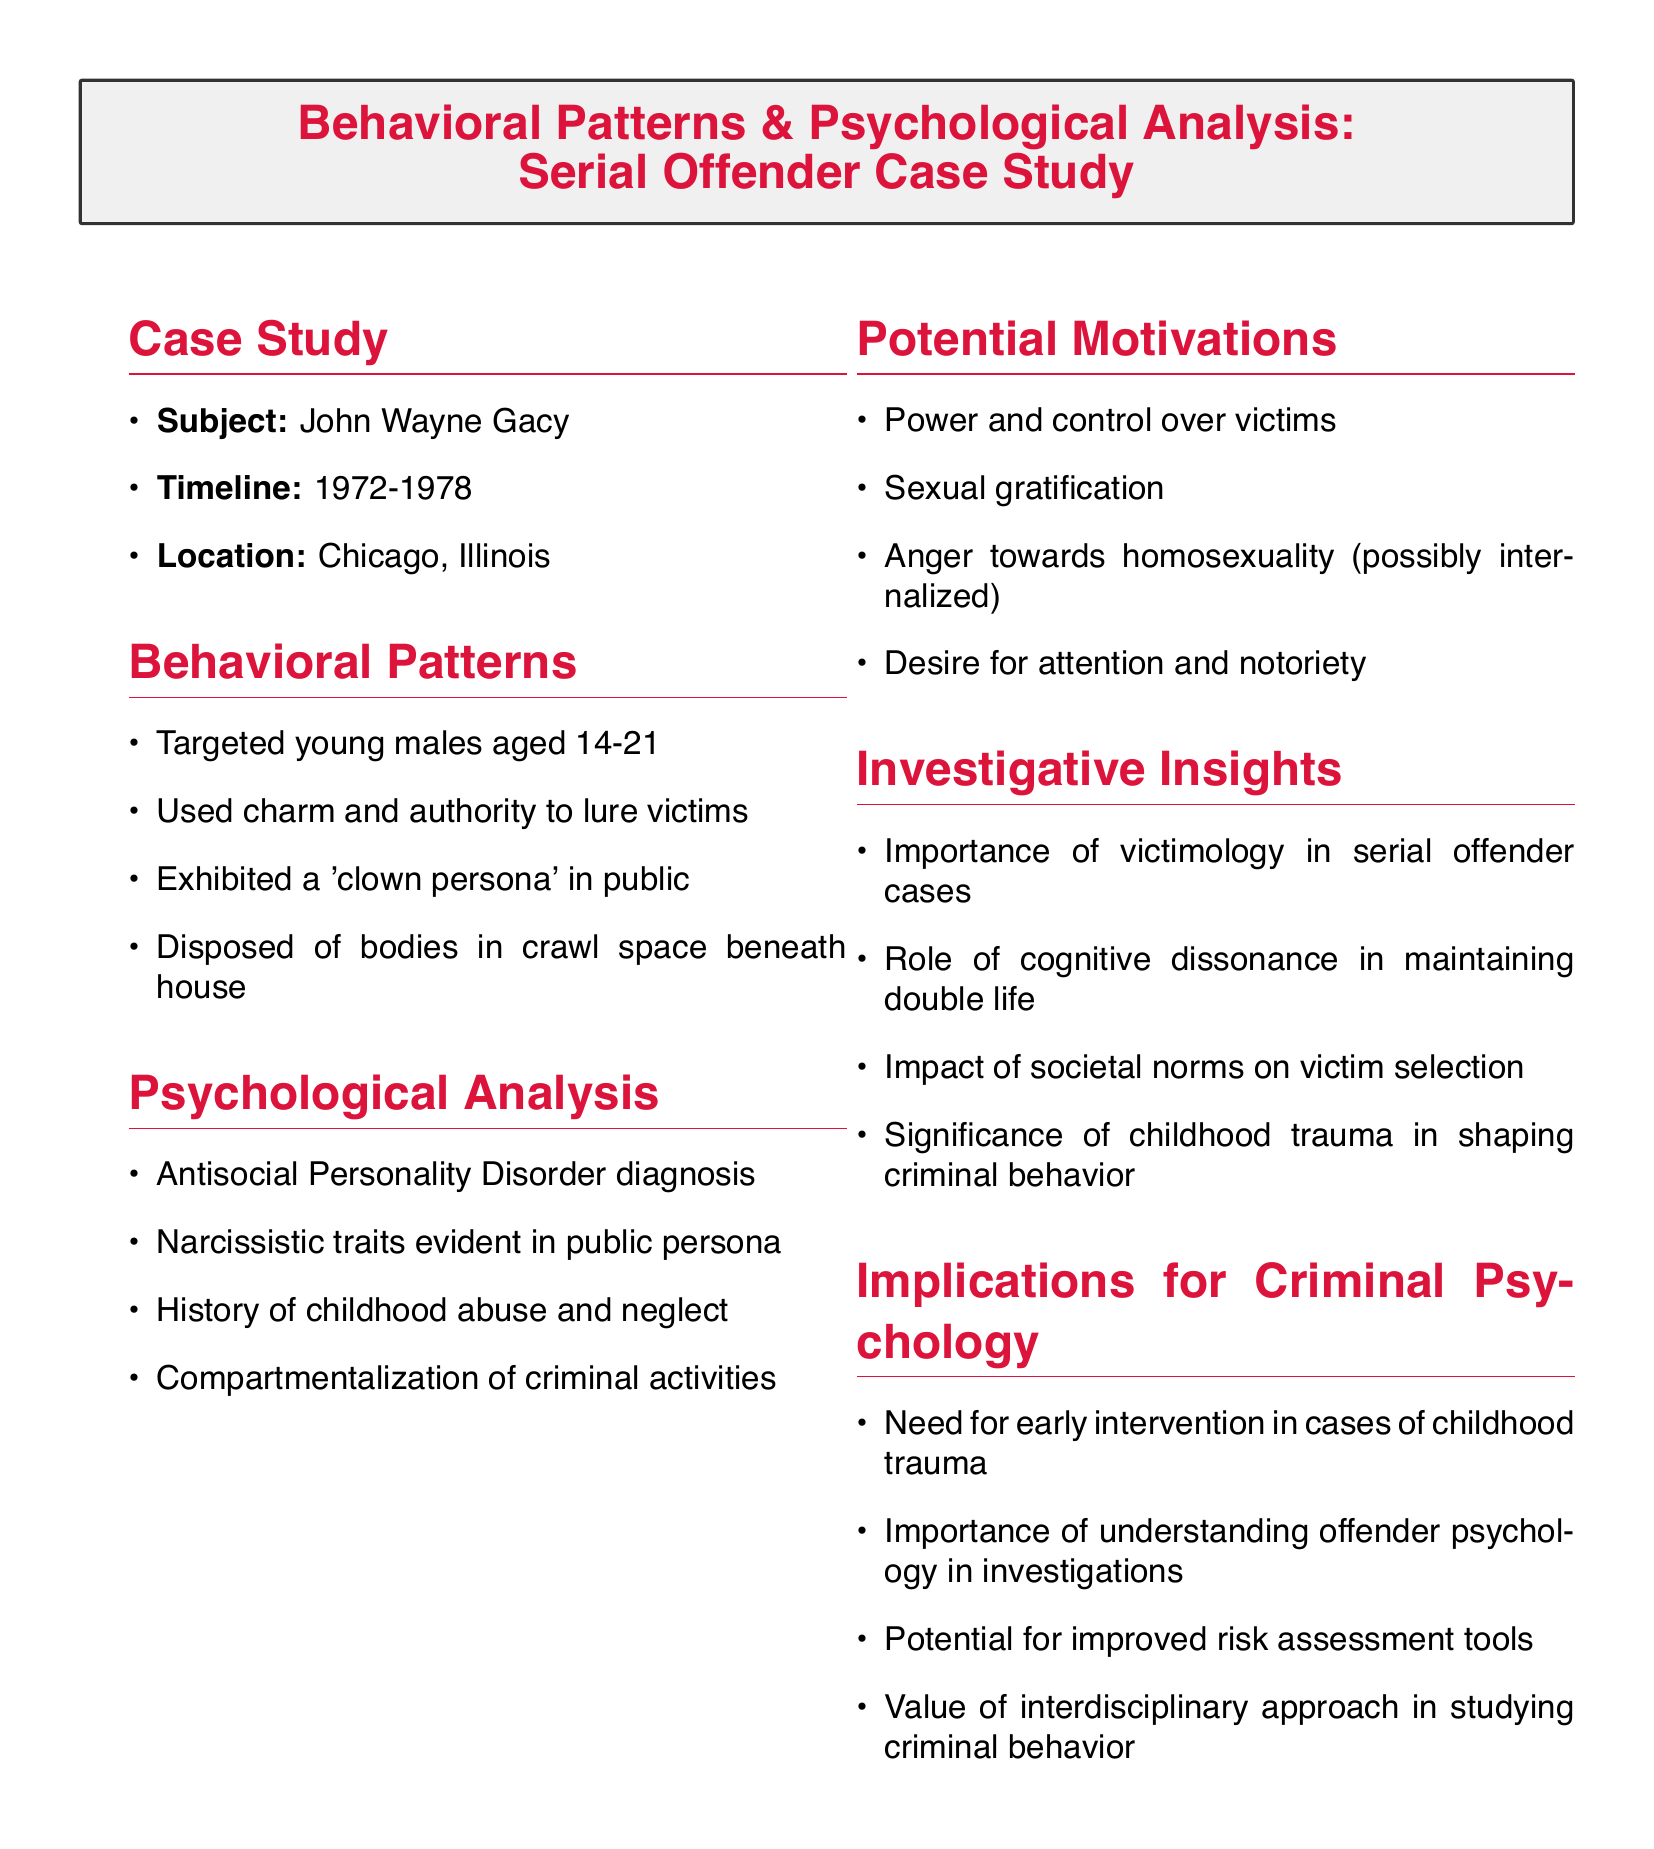What was the subject of the case study? The subject is the individual whose behaviors and psychological analysis are explored, which is John Wayne Gacy.
Answer: John Wayne Gacy What years did the case study cover? The timeline provides the period during which the documented offenses occurred, which is from 1972 to 1978.
Answer: 1972-1978 What disorder was John Wayne Gacy diagnosed with? The document specifically states the mental health diagnosis associated with the subject, which is Antisocial Personality Disorder.
Answer: Antisocial Personality Disorder How did Gacy dispose of his victims' bodies? The method of body disposal is noted as a significant behavior, specifically indicating where the bodies were hidden.
Answer: Crawl space beneath house What was one of the potential motivations for Gacy's actions? Among the various motivations listed, one that stands out is the need for power and control over victims.
Answer: Power and control What role does childhood trauma play in understanding criminal behavior? The document discusses how childhood trauma is significant in shaping behaviors associated with criminality, highlighting its impact on offenders.
Answer: Shaping criminal behavior Why is victimology important in serial offender cases? The insights provided in the document indicate that understanding victim dynamics is critical in the analysis of offenders' behaviors and patterns.
Answer: Importance of victimology What psychological traits are evident in Gacy's public persona? The document lists specific psychological characteristics, notably indicating narcissistic traits evident in his social interactions.
Answer: Narcissistic traits What is the significance of cognitive dissonance in Gacy's life? The insights relate to maintaining a double life, emphasizing how cognitive dissonance allowed Gacy to navigate his criminal activities.
Answer: Maintaining double life 